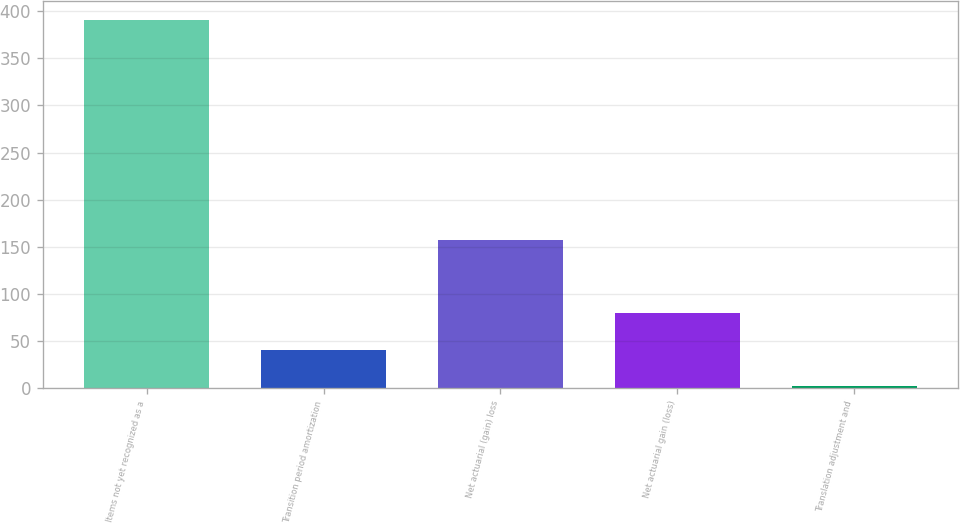<chart> <loc_0><loc_0><loc_500><loc_500><bar_chart><fcel>Items not yet recognized as a<fcel>Transition period amortization<fcel>Net actuarial (gain) loss<fcel>Net actuarial gain (loss)<fcel>Translation adjustment and<nl><fcel>391<fcel>40.9<fcel>157.6<fcel>79.8<fcel>2<nl></chart> 